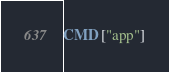Convert code to text. <code><loc_0><loc_0><loc_500><loc_500><_Dockerfile_>
CMD ["app"]</code> 